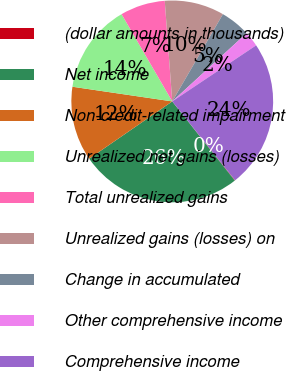<chart> <loc_0><loc_0><loc_500><loc_500><pie_chart><fcel>(dollar amounts in thousands)<fcel>Net income<fcel>Non-credit-related impairment<fcel>Unrealized net gains (losses)<fcel>Total unrealized gains<fcel>Unrealized gains (losses) on<fcel>Change in accumulated<fcel>Other comprehensive income<fcel>Comprehensive income<nl><fcel>0.07%<fcel>26.03%<fcel>11.93%<fcel>14.3%<fcel>7.19%<fcel>9.56%<fcel>4.81%<fcel>2.44%<fcel>23.66%<nl></chart> 